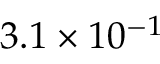Convert formula to latex. <formula><loc_0><loc_0><loc_500><loc_500>3 . 1 \times 1 0 ^ { - 1 }</formula> 